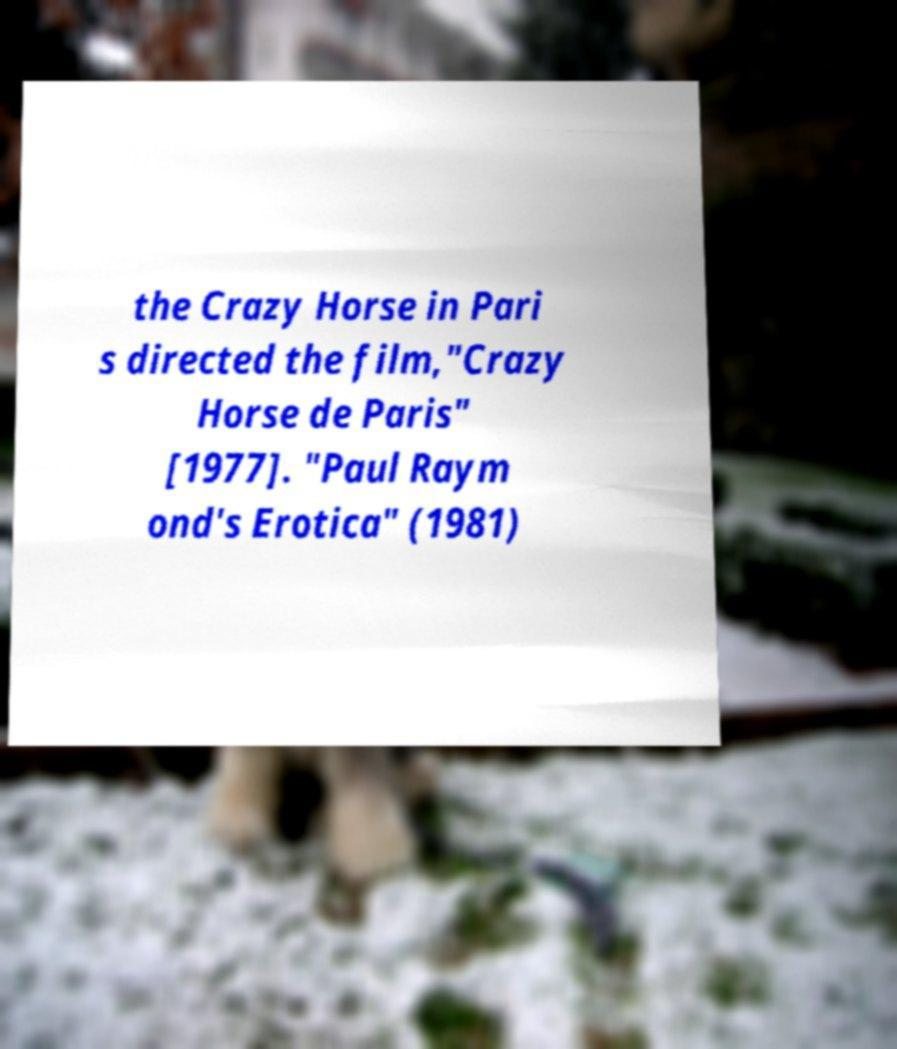Can you accurately transcribe the text from the provided image for me? the Crazy Horse in Pari s directed the film,"Crazy Horse de Paris" [1977]. "Paul Raym ond's Erotica" (1981) 